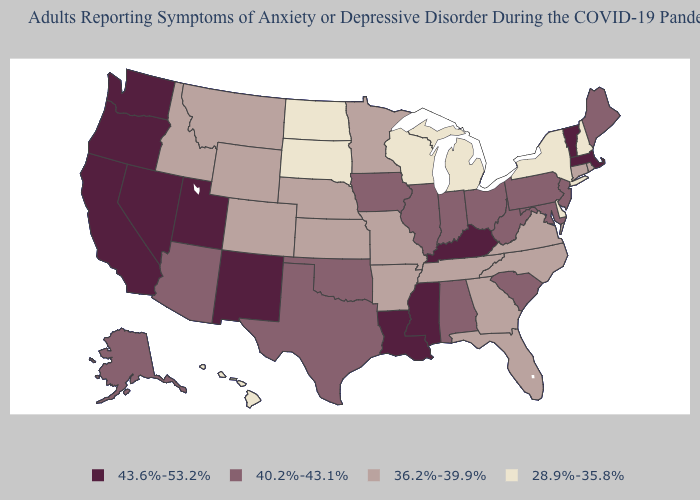Name the states that have a value in the range 40.2%-43.1%?
Concise answer only. Alabama, Alaska, Arizona, Illinois, Indiana, Iowa, Maine, Maryland, New Jersey, Ohio, Oklahoma, Pennsylvania, South Carolina, Texas, West Virginia. Does Kentucky have the highest value in the USA?
Keep it brief. Yes. Among the states that border Massachusetts , which have the lowest value?
Be succinct. New Hampshire, New York. Name the states that have a value in the range 28.9%-35.8%?
Keep it brief. Delaware, Hawaii, Michigan, New Hampshire, New York, North Dakota, South Dakota, Wisconsin. What is the value of New Mexico?
Keep it brief. 43.6%-53.2%. What is the lowest value in the MidWest?
Keep it brief. 28.9%-35.8%. Name the states that have a value in the range 36.2%-39.9%?
Concise answer only. Arkansas, Colorado, Connecticut, Florida, Georgia, Idaho, Kansas, Minnesota, Missouri, Montana, Nebraska, North Carolina, Rhode Island, Tennessee, Virginia, Wyoming. What is the highest value in states that border Indiana?
Be succinct. 43.6%-53.2%. Name the states that have a value in the range 36.2%-39.9%?
Quick response, please. Arkansas, Colorado, Connecticut, Florida, Georgia, Idaho, Kansas, Minnesota, Missouri, Montana, Nebraska, North Carolina, Rhode Island, Tennessee, Virginia, Wyoming. Which states have the lowest value in the USA?
Short answer required. Delaware, Hawaii, Michigan, New Hampshire, New York, North Dakota, South Dakota, Wisconsin. Does Mississippi have the highest value in the USA?
Quick response, please. Yes. What is the highest value in states that border Michigan?
Answer briefly. 40.2%-43.1%. What is the highest value in states that border Oklahoma?
Write a very short answer. 43.6%-53.2%. Does South Dakota have the lowest value in the USA?
Be succinct. Yes. Which states hav the highest value in the Northeast?
Quick response, please. Massachusetts, Vermont. 